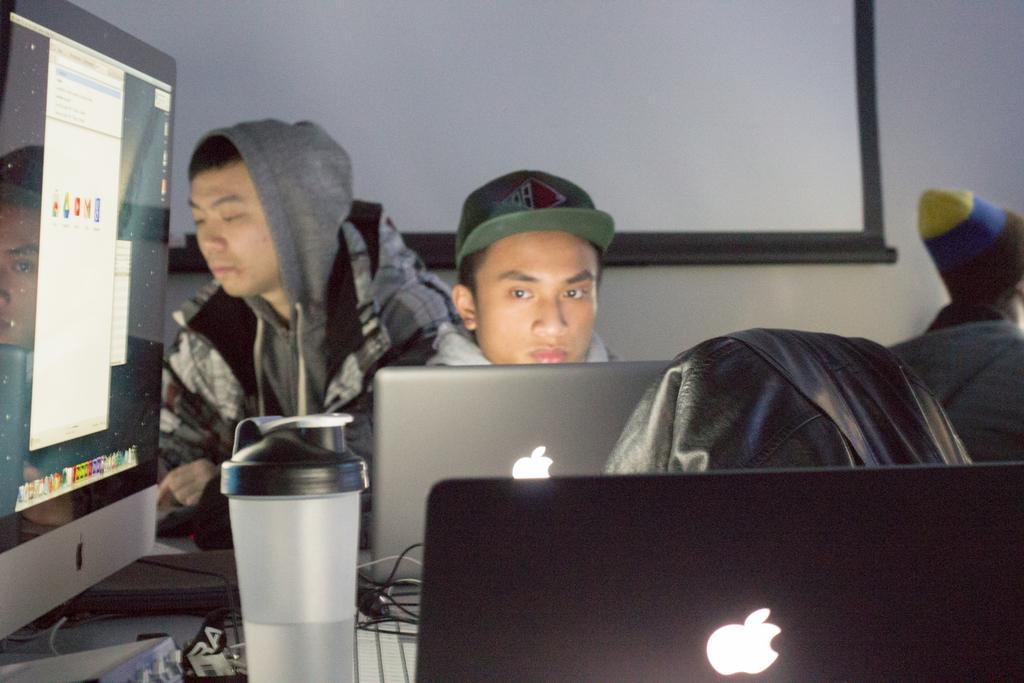How would you summarize this image in a sentence or two? In the image there are three people and two of them are working with laptops and other gadgets, there is a bottle kept beside one of the laptop and in the background there is a projector screen in front of the wall and on the the right side of the wall there is another person. 